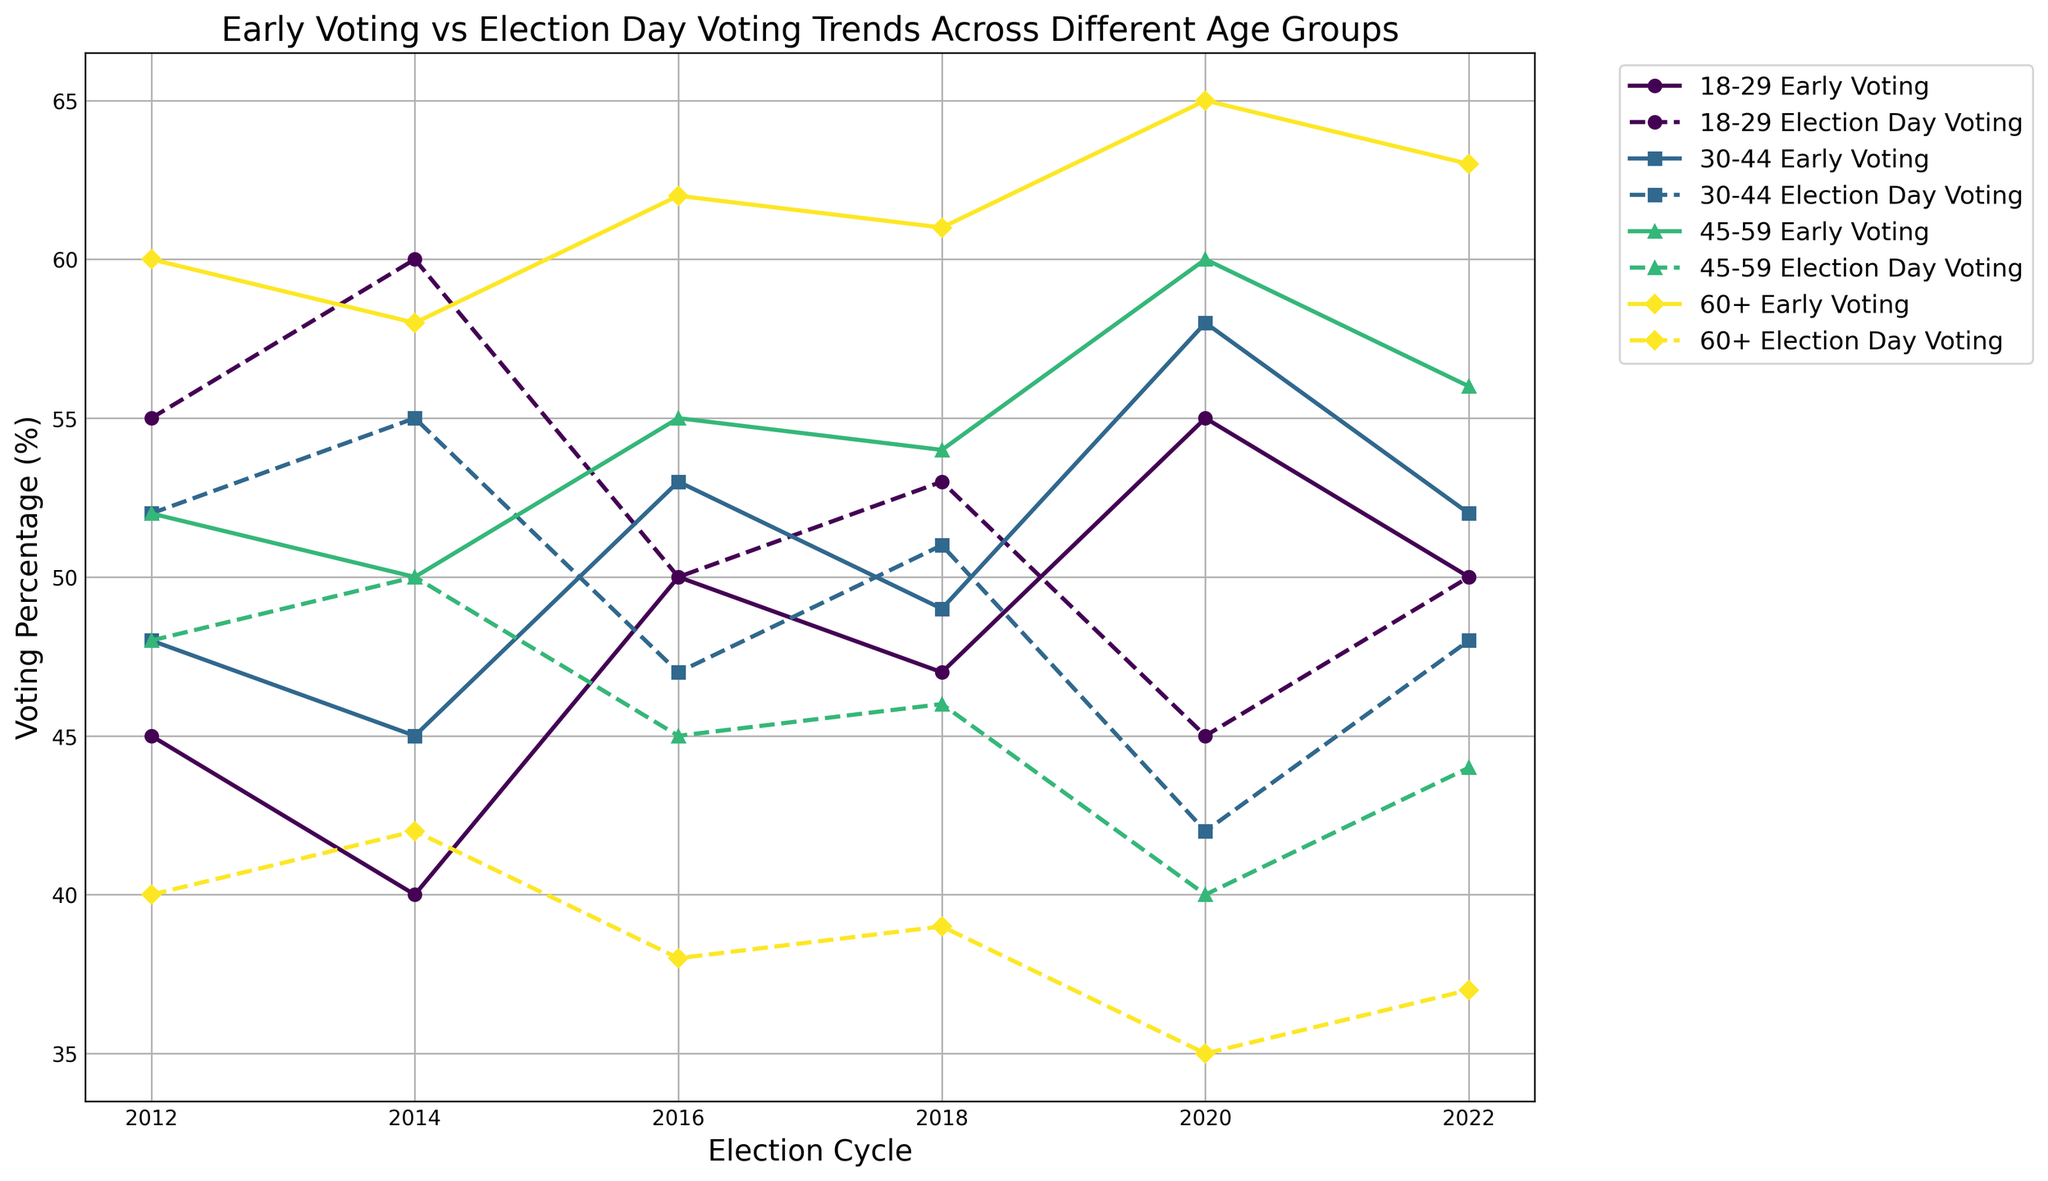What trend do you observe in early voting percentages among the 60+ age group across the election cycles? To identify the trend, observe the line representing the 60+ age group's early voting percentage. It starts at 60% in 2012 and generally increases over the subsequent election cycles, reaching a peak of 65% in 2020 before slightly decreasing to 63% in 2022. This indicates an overall upward trend in early voting participation among the 60+ age group.
Answer: Upward trend Which age group had the highest percentage of early voting in the 2020 election cycle? Observe the lines for all age groups in the 2020 election cycle and identify the highest point. The 60+ age group had the highest early voting percentage at 65%.
Answer: 60+ age group How does the early voting percentage of the 18-29 age group in 2012 compare to their election day voting percentage? For 2012, look at the early voting and election day voting lines corresponding to the 18-29 age group. The early voting percentage is 45%, while the election day voting percentage is 55%.
Answer: Early voting is 10% lower than election day voting Which age group's early voting percentage decreased the most from 2016 to 2018? Check the early voting percentages for all age groups in 2016 and compare them with their respective percentages in 2018. The 18-29 age group's early voting percentage decreased from 50% in 2016 to 47% in 2018, a decrease of 3%.
Answer: 18-29 age group Calculate the average early voting percentage across all age groups in the 2016 election cycle. Sum the early voting percentages for all age groups in the 2016 election cycle (50% + 53% + 55% + 62%) and divide by the number of age groups, which is 4. The average is (50 + 53 + 55 + 62) / 4 = 55%.
Answer: 55% In which election cycle did the 45-59 age group have equal percentages for early voting and election day voting? Look for a point where the early voting and election day voting lines intersect for the 45-59 age group. This happens in the 2014 election cycle, where both percentages are 50%.
Answer: 2014 Compare the early voting trends of the 30-44 and 60+ age groups from 2014 to 2018. Observe the lines representing early voting for the 30-44 and 60+ age groups between 2014 and 2018. The 30-44 age group's early voting percentage increased from 45% to 49%, while the 60+ age group's early voting increased from 58% to 61%. Both groups show an increasing trend, but the 60+ group had a greater increase in percentage points.
Answer: Both increased, 60+ had greater increase What is the difference in early voting percentage between the 18-29 and 60+ age groups in the 2018 election cycle? Identify the early voting percentages for the 18-29 (47%) and 60+ (61%) age groups in 2018, and calculate the difference: 61% - 47% = 14%.
Answer: 14% 